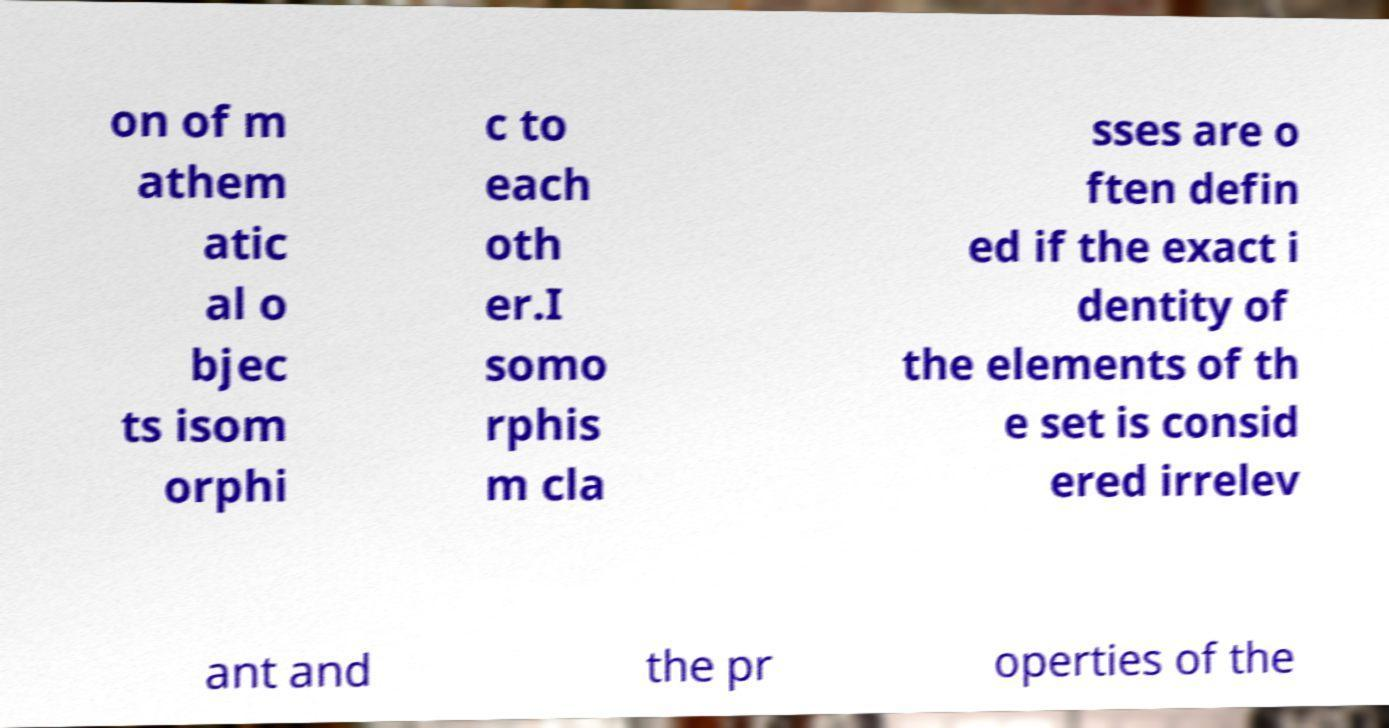For documentation purposes, I need the text within this image transcribed. Could you provide that? on of m athem atic al o bjec ts isom orphi c to each oth er.I somo rphis m cla sses are o ften defin ed if the exact i dentity of the elements of th e set is consid ered irrelev ant and the pr operties of the 